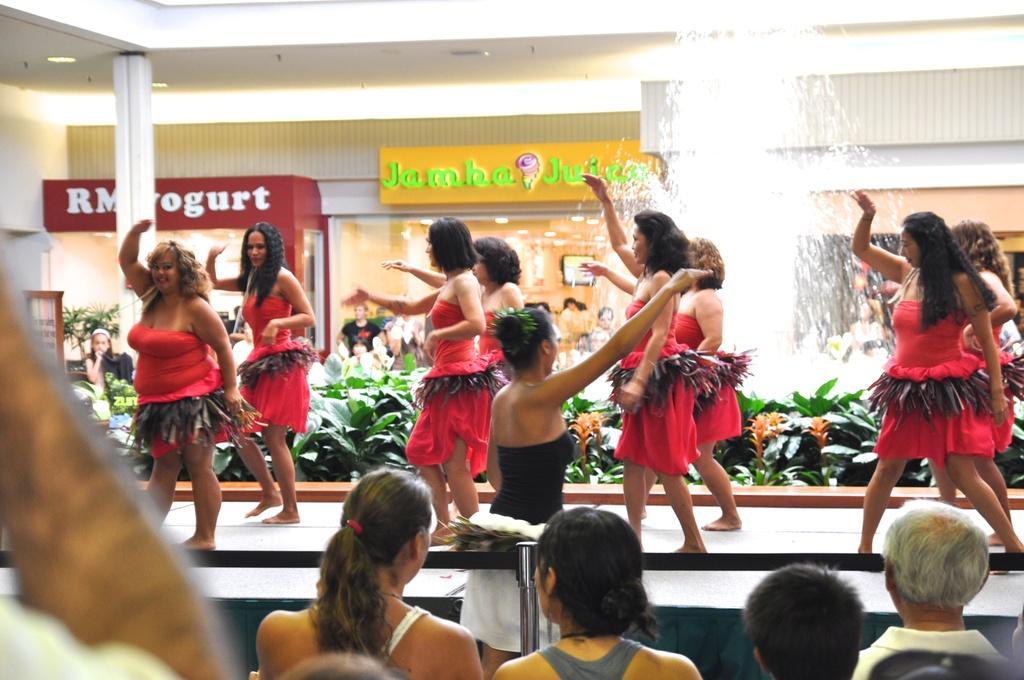How would you summarize this image in a sentence or two? In this picture there are girls in the center of the image on the stage, they are dancing, there is a fountain on the right side of the image and there are other people at the bottom side of the image. 